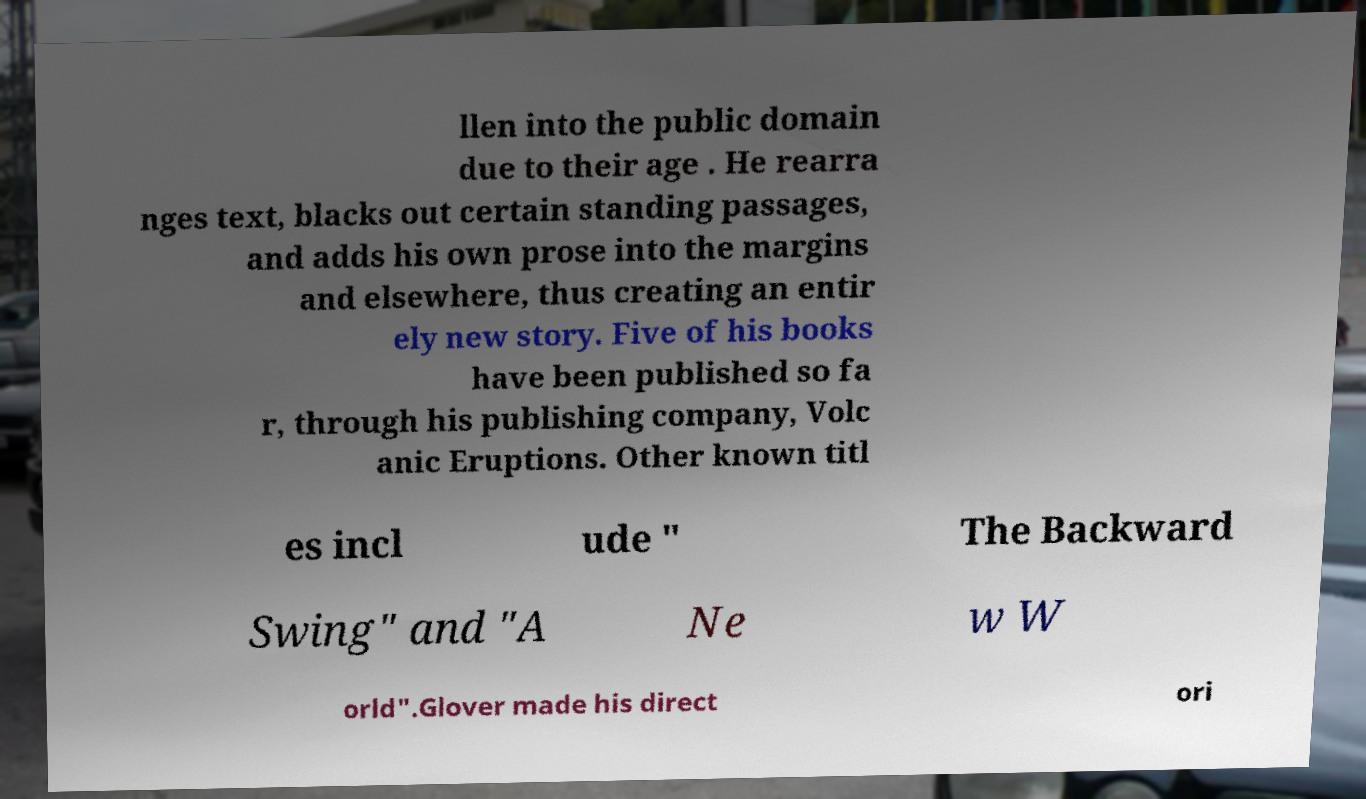Please identify and transcribe the text found in this image. llen into the public domain due to their age . He rearra nges text, blacks out certain standing passages, and adds his own prose into the margins and elsewhere, thus creating an entir ely new story. Five of his books have been published so fa r, through his publishing company, Volc anic Eruptions. Other known titl es incl ude " The Backward Swing" and "A Ne w W orld".Glover made his direct ori 